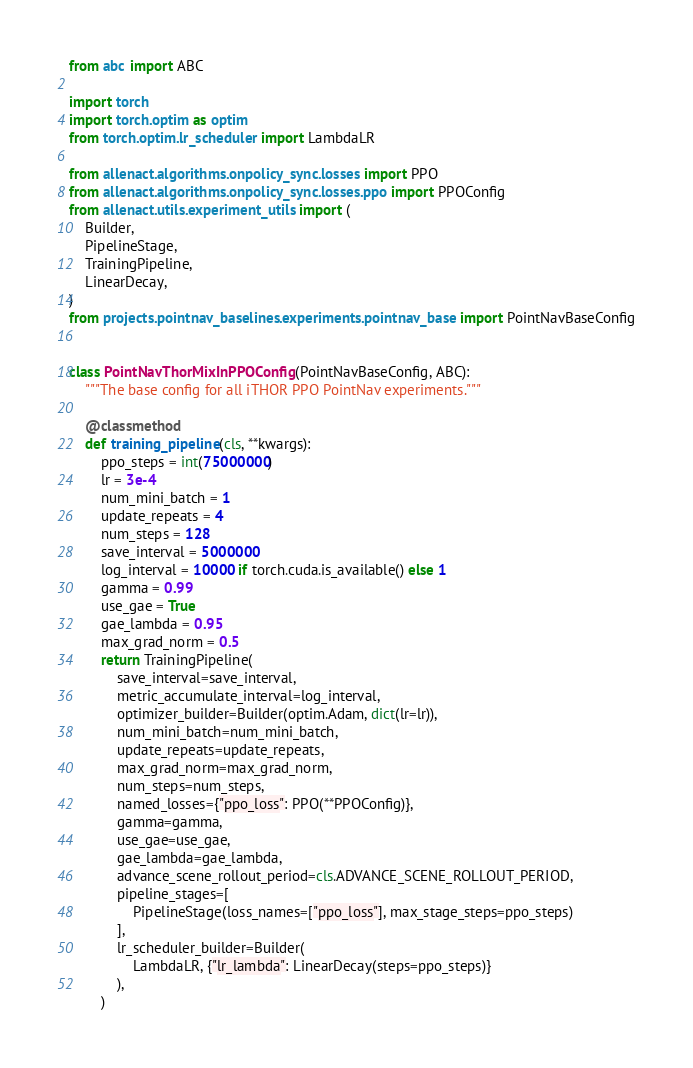<code> <loc_0><loc_0><loc_500><loc_500><_Python_>from abc import ABC

import torch
import torch.optim as optim
from torch.optim.lr_scheduler import LambdaLR

from allenact.algorithms.onpolicy_sync.losses import PPO
from allenact.algorithms.onpolicy_sync.losses.ppo import PPOConfig
from allenact.utils.experiment_utils import (
    Builder,
    PipelineStage,
    TrainingPipeline,
    LinearDecay,
)
from projects.pointnav_baselines.experiments.pointnav_base import PointNavBaseConfig


class PointNavThorMixInPPOConfig(PointNavBaseConfig, ABC):
    """The base config for all iTHOR PPO PointNav experiments."""

    @classmethod
    def training_pipeline(cls, **kwargs):
        ppo_steps = int(75000000)
        lr = 3e-4
        num_mini_batch = 1
        update_repeats = 4
        num_steps = 128
        save_interval = 5000000
        log_interval = 10000 if torch.cuda.is_available() else 1
        gamma = 0.99
        use_gae = True
        gae_lambda = 0.95
        max_grad_norm = 0.5
        return TrainingPipeline(
            save_interval=save_interval,
            metric_accumulate_interval=log_interval,
            optimizer_builder=Builder(optim.Adam, dict(lr=lr)),
            num_mini_batch=num_mini_batch,
            update_repeats=update_repeats,
            max_grad_norm=max_grad_norm,
            num_steps=num_steps,
            named_losses={"ppo_loss": PPO(**PPOConfig)},
            gamma=gamma,
            use_gae=use_gae,
            gae_lambda=gae_lambda,
            advance_scene_rollout_period=cls.ADVANCE_SCENE_ROLLOUT_PERIOD,
            pipeline_stages=[
                PipelineStage(loss_names=["ppo_loss"], max_stage_steps=ppo_steps)
            ],
            lr_scheduler_builder=Builder(
                LambdaLR, {"lr_lambda": LinearDecay(steps=ppo_steps)}
            ),
        )
</code> 